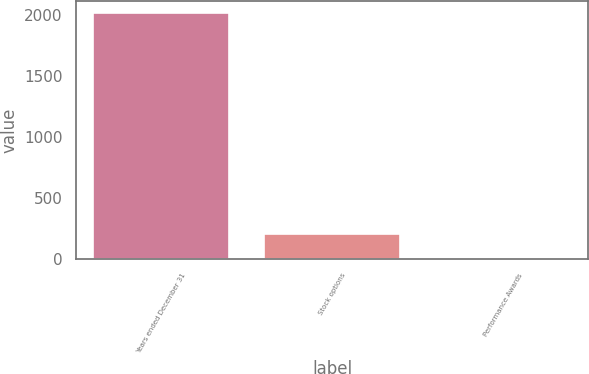Convert chart to OTSL. <chart><loc_0><loc_0><loc_500><loc_500><bar_chart><fcel>Years ended December 31<fcel>Stock options<fcel>Performance Awards<nl><fcel>2011<fcel>202.45<fcel>1.5<nl></chart> 